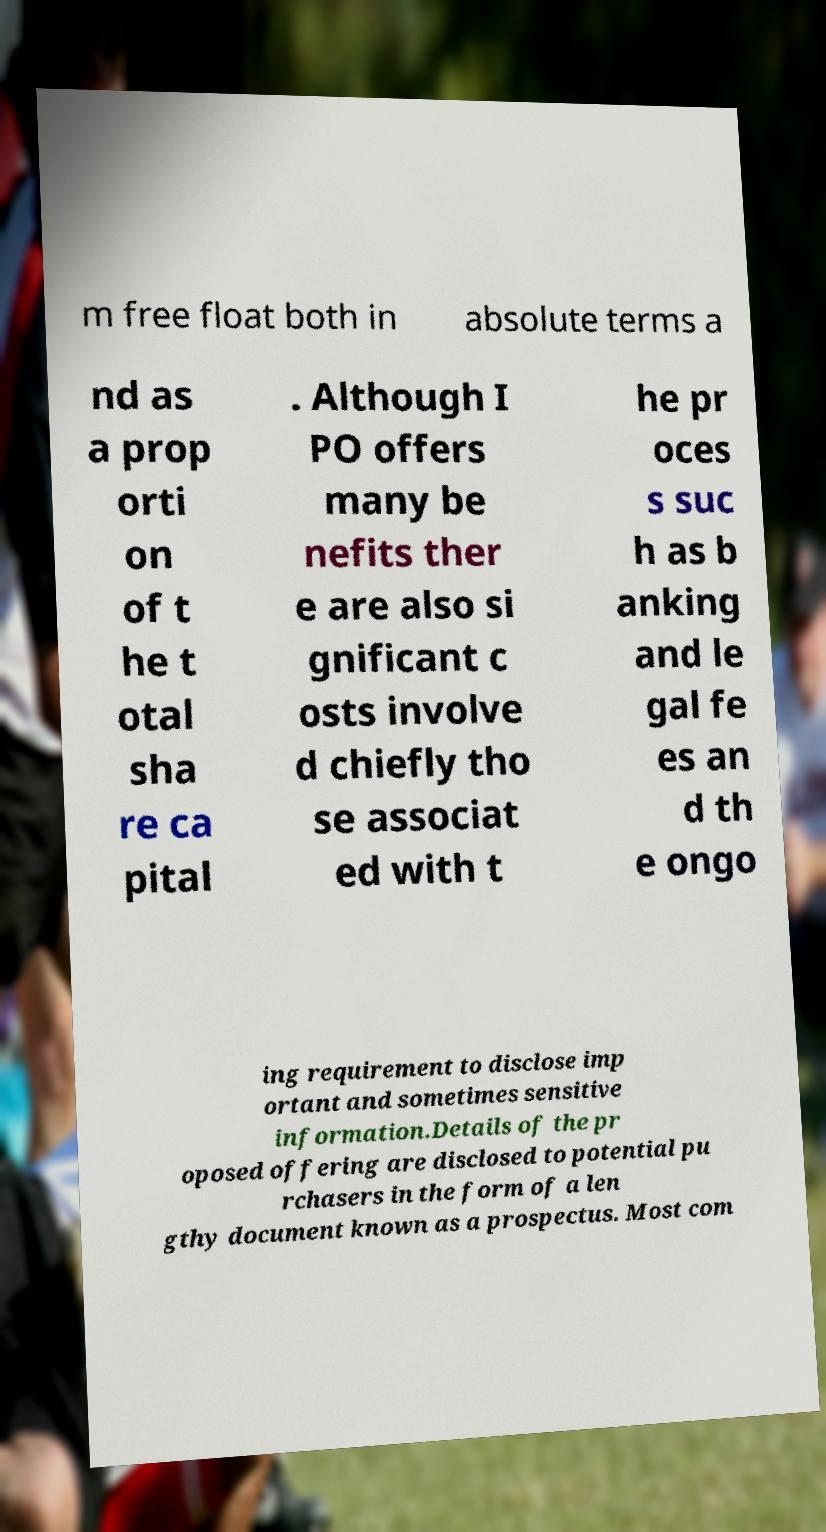Please identify and transcribe the text found in this image. m free float both in absolute terms a nd as a prop orti on of t he t otal sha re ca pital . Although I PO offers many be nefits ther e are also si gnificant c osts involve d chiefly tho se associat ed with t he pr oces s suc h as b anking and le gal fe es an d th e ongo ing requirement to disclose imp ortant and sometimes sensitive information.Details of the pr oposed offering are disclosed to potential pu rchasers in the form of a len gthy document known as a prospectus. Most com 